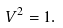<formula> <loc_0><loc_0><loc_500><loc_500>V ^ { 2 } = 1 .</formula> 